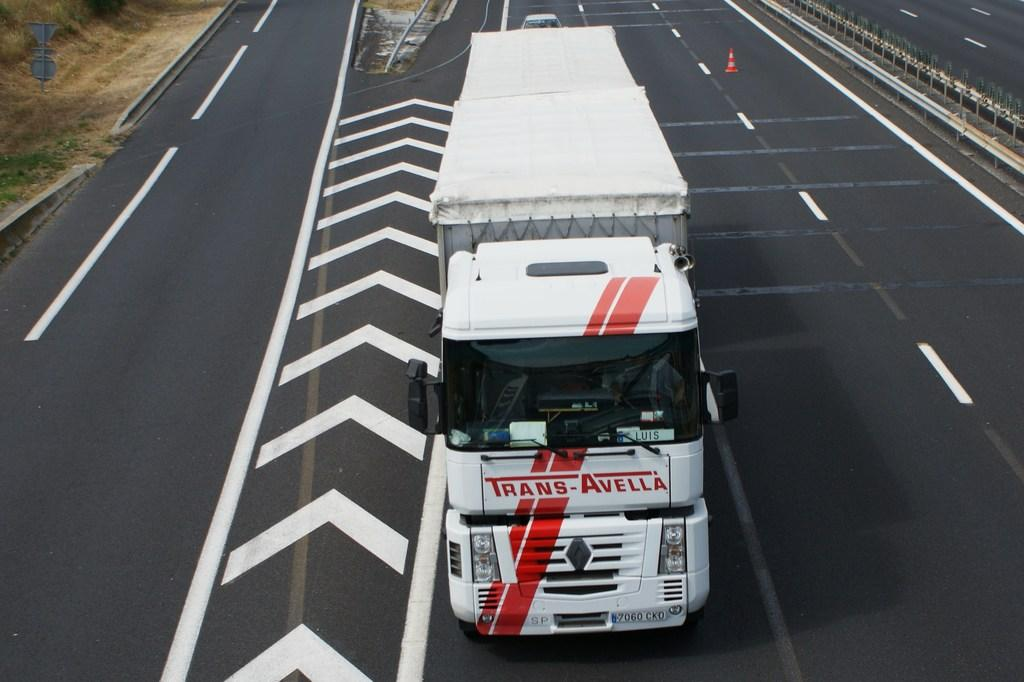What can be seen on the road in the image? There are vehicles on the road in the image. What type of barrier is visible alongside the road? There is a fence visible in the image. What markings are present on the road? White color lines are present on the road in the image. Can you describe any other elements in the image? There are other unspecified elements in the image. What type of engine is powering the trick in the image? There is no trick or engine present in the image. What type of business is being conducted in the image? There is no business activity depicted in the image. 